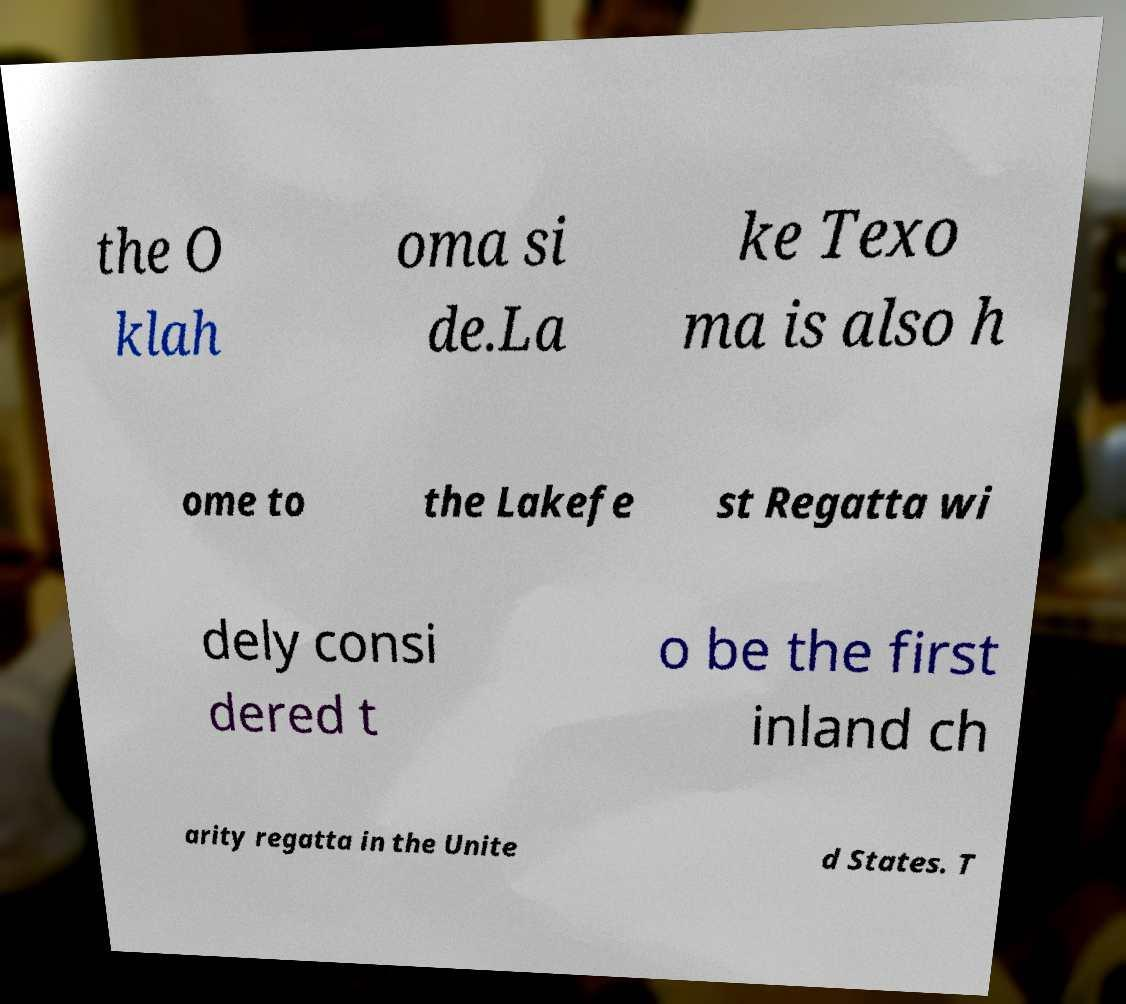There's text embedded in this image that I need extracted. Can you transcribe it verbatim? the O klah oma si de.La ke Texo ma is also h ome to the Lakefe st Regatta wi dely consi dered t o be the first inland ch arity regatta in the Unite d States. T 